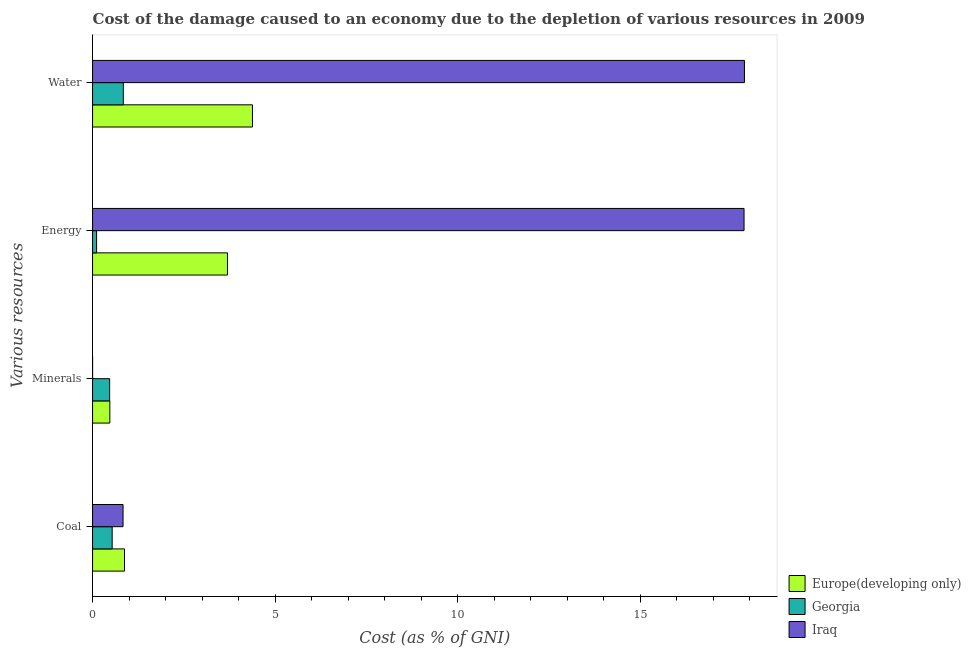Are the number of bars per tick equal to the number of legend labels?
Your answer should be compact. Yes. Are the number of bars on each tick of the Y-axis equal?
Keep it short and to the point. Yes. What is the label of the 1st group of bars from the top?
Give a very brief answer. Water. What is the cost of damage due to depletion of minerals in Europe(developing only)?
Your response must be concise. 0.47. Across all countries, what is the maximum cost of damage due to depletion of minerals?
Your answer should be very brief. 0.47. Across all countries, what is the minimum cost of damage due to depletion of water?
Your answer should be compact. 0.84. In which country was the cost of damage due to depletion of water maximum?
Your answer should be compact. Iraq. In which country was the cost of damage due to depletion of energy minimum?
Keep it short and to the point. Georgia. What is the total cost of damage due to depletion of energy in the graph?
Provide a short and direct response. 21.66. What is the difference between the cost of damage due to depletion of minerals in Georgia and that in Europe(developing only)?
Make the answer very short. -0.01. What is the difference between the cost of damage due to depletion of coal in Iraq and the cost of damage due to depletion of energy in Europe(developing only)?
Ensure brevity in your answer.  -2.86. What is the average cost of damage due to depletion of energy per country?
Your answer should be compact. 7.22. What is the difference between the cost of damage due to depletion of minerals and cost of damage due to depletion of coal in Europe(developing only)?
Ensure brevity in your answer.  -0.4. In how many countries, is the cost of damage due to depletion of minerals greater than 3 %?
Provide a succinct answer. 0. What is the ratio of the cost of damage due to depletion of energy in Georgia to that in Iraq?
Keep it short and to the point. 0.01. Is the cost of damage due to depletion of coal in Iraq less than that in Europe(developing only)?
Give a very brief answer. Yes. Is the difference between the cost of damage due to depletion of water in Europe(developing only) and Georgia greater than the difference between the cost of damage due to depletion of coal in Europe(developing only) and Georgia?
Offer a terse response. Yes. What is the difference between the highest and the second highest cost of damage due to depletion of coal?
Provide a succinct answer. 0.04. What is the difference between the highest and the lowest cost of damage due to depletion of water?
Keep it short and to the point. 17.02. In how many countries, is the cost of damage due to depletion of minerals greater than the average cost of damage due to depletion of minerals taken over all countries?
Your answer should be compact. 2. What does the 3rd bar from the top in Minerals represents?
Make the answer very short. Europe(developing only). What does the 2nd bar from the bottom in Energy represents?
Make the answer very short. Georgia. Is it the case that in every country, the sum of the cost of damage due to depletion of coal and cost of damage due to depletion of minerals is greater than the cost of damage due to depletion of energy?
Your answer should be very brief. No. How many bars are there?
Keep it short and to the point. 12. How many countries are there in the graph?
Keep it short and to the point. 3. What is the difference between two consecutive major ticks on the X-axis?
Give a very brief answer. 5. Are the values on the major ticks of X-axis written in scientific E-notation?
Ensure brevity in your answer.  No. Does the graph contain any zero values?
Provide a succinct answer. No. Does the graph contain grids?
Your response must be concise. No. Where does the legend appear in the graph?
Your answer should be compact. Bottom right. How many legend labels are there?
Make the answer very short. 3. How are the legend labels stacked?
Offer a terse response. Vertical. What is the title of the graph?
Your answer should be compact. Cost of the damage caused to an economy due to the depletion of various resources in 2009 . Does "Liberia" appear as one of the legend labels in the graph?
Keep it short and to the point. No. What is the label or title of the X-axis?
Keep it short and to the point. Cost (as % of GNI). What is the label or title of the Y-axis?
Provide a short and direct response. Various resources. What is the Cost (as % of GNI) in Europe(developing only) in Coal?
Your response must be concise. 0.87. What is the Cost (as % of GNI) of Georgia in Coal?
Keep it short and to the point. 0.54. What is the Cost (as % of GNI) of Iraq in Coal?
Offer a terse response. 0.84. What is the Cost (as % of GNI) in Europe(developing only) in Minerals?
Provide a succinct answer. 0.47. What is the Cost (as % of GNI) of Georgia in Minerals?
Keep it short and to the point. 0.47. What is the Cost (as % of GNI) in Iraq in Minerals?
Offer a very short reply. 0. What is the Cost (as % of GNI) of Europe(developing only) in Energy?
Offer a terse response. 3.7. What is the Cost (as % of GNI) in Georgia in Energy?
Your answer should be compact. 0.11. What is the Cost (as % of GNI) of Iraq in Energy?
Keep it short and to the point. 17.85. What is the Cost (as % of GNI) of Europe(developing only) in Water?
Keep it short and to the point. 4.38. What is the Cost (as % of GNI) of Georgia in Water?
Offer a very short reply. 0.84. What is the Cost (as % of GNI) in Iraq in Water?
Make the answer very short. 17.86. Across all Various resources, what is the maximum Cost (as % of GNI) of Europe(developing only)?
Provide a short and direct response. 4.38. Across all Various resources, what is the maximum Cost (as % of GNI) in Georgia?
Provide a succinct answer. 0.84. Across all Various resources, what is the maximum Cost (as % of GNI) of Iraq?
Offer a very short reply. 17.86. Across all Various resources, what is the minimum Cost (as % of GNI) in Europe(developing only)?
Your response must be concise. 0.47. Across all Various resources, what is the minimum Cost (as % of GNI) of Georgia?
Provide a succinct answer. 0.11. Across all Various resources, what is the minimum Cost (as % of GNI) of Iraq?
Keep it short and to the point. 0. What is the total Cost (as % of GNI) in Europe(developing only) in the graph?
Provide a succinct answer. 9.42. What is the total Cost (as % of GNI) of Georgia in the graph?
Give a very brief answer. 1.96. What is the total Cost (as % of GNI) in Iraq in the graph?
Your answer should be compact. 36.55. What is the difference between the Cost (as % of GNI) in Europe(developing only) in Coal and that in Minerals?
Give a very brief answer. 0.4. What is the difference between the Cost (as % of GNI) in Georgia in Coal and that in Minerals?
Make the answer very short. 0.07. What is the difference between the Cost (as % of GNI) of Iraq in Coal and that in Minerals?
Keep it short and to the point. 0.83. What is the difference between the Cost (as % of GNI) of Europe(developing only) in Coal and that in Energy?
Your answer should be very brief. -2.82. What is the difference between the Cost (as % of GNI) of Georgia in Coal and that in Energy?
Make the answer very short. 0.43. What is the difference between the Cost (as % of GNI) in Iraq in Coal and that in Energy?
Offer a terse response. -17.02. What is the difference between the Cost (as % of GNI) of Europe(developing only) in Coal and that in Water?
Your answer should be compact. -3.51. What is the difference between the Cost (as % of GNI) in Georgia in Coal and that in Water?
Offer a terse response. -0.31. What is the difference between the Cost (as % of GNI) in Iraq in Coal and that in Water?
Keep it short and to the point. -17.03. What is the difference between the Cost (as % of GNI) in Europe(developing only) in Minerals and that in Energy?
Keep it short and to the point. -3.22. What is the difference between the Cost (as % of GNI) of Georgia in Minerals and that in Energy?
Make the answer very short. 0.36. What is the difference between the Cost (as % of GNI) in Iraq in Minerals and that in Energy?
Offer a very short reply. -17.85. What is the difference between the Cost (as % of GNI) of Europe(developing only) in Minerals and that in Water?
Provide a short and direct response. -3.91. What is the difference between the Cost (as % of GNI) of Georgia in Minerals and that in Water?
Your response must be concise. -0.38. What is the difference between the Cost (as % of GNI) in Iraq in Minerals and that in Water?
Provide a short and direct response. -17.86. What is the difference between the Cost (as % of GNI) of Europe(developing only) in Energy and that in Water?
Your answer should be very brief. -0.68. What is the difference between the Cost (as % of GNI) of Georgia in Energy and that in Water?
Offer a terse response. -0.73. What is the difference between the Cost (as % of GNI) of Iraq in Energy and that in Water?
Your answer should be compact. -0.01. What is the difference between the Cost (as % of GNI) of Europe(developing only) in Coal and the Cost (as % of GNI) of Georgia in Minerals?
Provide a succinct answer. 0.41. What is the difference between the Cost (as % of GNI) in Europe(developing only) in Coal and the Cost (as % of GNI) in Iraq in Minerals?
Keep it short and to the point. 0.87. What is the difference between the Cost (as % of GNI) of Georgia in Coal and the Cost (as % of GNI) of Iraq in Minerals?
Provide a succinct answer. 0.54. What is the difference between the Cost (as % of GNI) in Europe(developing only) in Coal and the Cost (as % of GNI) in Georgia in Energy?
Your answer should be very brief. 0.76. What is the difference between the Cost (as % of GNI) in Europe(developing only) in Coal and the Cost (as % of GNI) in Iraq in Energy?
Offer a terse response. -16.98. What is the difference between the Cost (as % of GNI) of Georgia in Coal and the Cost (as % of GNI) of Iraq in Energy?
Offer a terse response. -17.31. What is the difference between the Cost (as % of GNI) of Europe(developing only) in Coal and the Cost (as % of GNI) of Georgia in Water?
Give a very brief answer. 0.03. What is the difference between the Cost (as % of GNI) in Europe(developing only) in Coal and the Cost (as % of GNI) in Iraq in Water?
Give a very brief answer. -16.99. What is the difference between the Cost (as % of GNI) of Georgia in Coal and the Cost (as % of GNI) of Iraq in Water?
Ensure brevity in your answer.  -17.32. What is the difference between the Cost (as % of GNI) of Europe(developing only) in Minerals and the Cost (as % of GNI) of Georgia in Energy?
Provide a succinct answer. 0.36. What is the difference between the Cost (as % of GNI) in Europe(developing only) in Minerals and the Cost (as % of GNI) in Iraq in Energy?
Offer a very short reply. -17.38. What is the difference between the Cost (as % of GNI) of Georgia in Minerals and the Cost (as % of GNI) of Iraq in Energy?
Make the answer very short. -17.38. What is the difference between the Cost (as % of GNI) in Europe(developing only) in Minerals and the Cost (as % of GNI) in Georgia in Water?
Provide a short and direct response. -0.37. What is the difference between the Cost (as % of GNI) of Europe(developing only) in Minerals and the Cost (as % of GNI) of Iraq in Water?
Offer a terse response. -17.39. What is the difference between the Cost (as % of GNI) of Georgia in Minerals and the Cost (as % of GNI) of Iraq in Water?
Make the answer very short. -17.39. What is the difference between the Cost (as % of GNI) in Europe(developing only) in Energy and the Cost (as % of GNI) in Georgia in Water?
Provide a short and direct response. 2.85. What is the difference between the Cost (as % of GNI) in Europe(developing only) in Energy and the Cost (as % of GNI) in Iraq in Water?
Offer a terse response. -14.17. What is the difference between the Cost (as % of GNI) in Georgia in Energy and the Cost (as % of GNI) in Iraq in Water?
Your answer should be very brief. -17.75. What is the average Cost (as % of GNI) in Europe(developing only) per Various resources?
Offer a terse response. 2.36. What is the average Cost (as % of GNI) of Georgia per Various resources?
Offer a terse response. 0.49. What is the average Cost (as % of GNI) in Iraq per Various resources?
Your response must be concise. 9.14. What is the difference between the Cost (as % of GNI) of Europe(developing only) and Cost (as % of GNI) of Georgia in Coal?
Keep it short and to the point. 0.34. What is the difference between the Cost (as % of GNI) in Europe(developing only) and Cost (as % of GNI) in Iraq in Coal?
Keep it short and to the point. 0.04. What is the difference between the Cost (as % of GNI) of Georgia and Cost (as % of GNI) of Iraq in Coal?
Your answer should be compact. -0.3. What is the difference between the Cost (as % of GNI) in Europe(developing only) and Cost (as % of GNI) in Georgia in Minerals?
Keep it short and to the point. 0.01. What is the difference between the Cost (as % of GNI) of Europe(developing only) and Cost (as % of GNI) of Iraq in Minerals?
Keep it short and to the point. 0.47. What is the difference between the Cost (as % of GNI) of Georgia and Cost (as % of GNI) of Iraq in Minerals?
Offer a very short reply. 0.47. What is the difference between the Cost (as % of GNI) of Europe(developing only) and Cost (as % of GNI) of Georgia in Energy?
Give a very brief answer. 3.59. What is the difference between the Cost (as % of GNI) in Europe(developing only) and Cost (as % of GNI) in Iraq in Energy?
Provide a succinct answer. -14.15. What is the difference between the Cost (as % of GNI) of Georgia and Cost (as % of GNI) of Iraq in Energy?
Keep it short and to the point. -17.74. What is the difference between the Cost (as % of GNI) of Europe(developing only) and Cost (as % of GNI) of Georgia in Water?
Your response must be concise. 3.54. What is the difference between the Cost (as % of GNI) of Europe(developing only) and Cost (as % of GNI) of Iraq in Water?
Your answer should be very brief. -13.48. What is the difference between the Cost (as % of GNI) in Georgia and Cost (as % of GNI) in Iraq in Water?
Keep it short and to the point. -17.02. What is the ratio of the Cost (as % of GNI) of Europe(developing only) in Coal to that in Minerals?
Your answer should be compact. 1.85. What is the ratio of the Cost (as % of GNI) of Georgia in Coal to that in Minerals?
Provide a succinct answer. 1.15. What is the ratio of the Cost (as % of GNI) in Iraq in Coal to that in Minerals?
Provide a succinct answer. 1933.56. What is the ratio of the Cost (as % of GNI) of Europe(developing only) in Coal to that in Energy?
Offer a very short reply. 0.24. What is the ratio of the Cost (as % of GNI) in Georgia in Coal to that in Energy?
Provide a short and direct response. 4.86. What is the ratio of the Cost (as % of GNI) of Iraq in Coal to that in Energy?
Offer a very short reply. 0.05. What is the ratio of the Cost (as % of GNI) in Europe(developing only) in Coal to that in Water?
Make the answer very short. 0.2. What is the ratio of the Cost (as % of GNI) of Georgia in Coal to that in Water?
Offer a very short reply. 0.64. What is the ratio of the Cost (as % of GNI) of Iraq in Coal to that in Water?
Ensure brevity in your answer.  0.05. What is the ratio of the Cost (as % of GNI) in Europe(developing only) in Minerals to that in Energy?
Give a very brief answer. 0.13. What is the ratio of the Cost (as % of GNI) of Georgia in Minerals to that in Energy?
Offer a terse response. 4.23. What is the ratio of the Cost (as % of GNI) in Europe(developing only) in Minerals to that in Water?
Ensure brevity in your answer.  0.11. What is the ratio of the Cost (as % of GNI) in Georgia in Minerals to that in Water?
Make the answer very short. 0.55. What is the ratio of the Cost (as % of GNI) in Europe(developing only) in Energy to that in Water?
Provide a succinct answer. 0.84. What is the ratio of the Cost (as % of GNI) of Georgia in Energy to that in Water?
Give a very brief answer. 0.13. What is the difference between the highest and the second highest Cost (as % of GNI) of Europe(developing only)?
Provide a short and direct response. 0.68. What is the difference between the highest and the second highest Cost (as % of GNI) in Georgia?
Provide a short and direct response. 0.31. What is the difference between the highest and the second highest Cost (as % of GNI) in Iraq?
Give a very brief answer. 0.01. What is the difference between the highest and the lowest Cost (as % of GNI) of Europe(developing only)?
Provide a succinct answer. 3.91. What is the difference between the highest and the lowest Cost (as % of GNI) in Georgia?
Offer a terse response. 0.73. What is the difference between the highest and the lowest Cost (as % of GNI) in Iraq?
Provide a succinct answer. 17.86. 